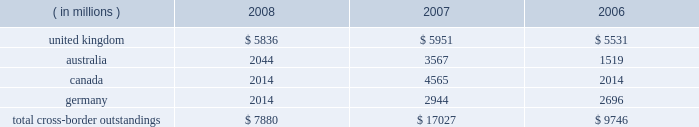Cross-border outstandings cross-border outstandings , as defined by bank regulatory rules , are amounts payable to state street by residents of foreign countries , regardless of the currency in which the claim is denominated , and local country claims in excess of local country obligations .
These cross-border outstandings consist primarily of deposits with banks , loan and lease financing and investment securities .
In addition to credit risk , cross-border outstandings have the risk that , as a result of political or economic conditions in a country , borrowers may be unable to meet their contractual repayment obligations of principal and/or interest when due because of the unavailability of , or restrictions on , foreign exchange needed by borrowers to repay their obligations .
Cross-border outstandings to countries in which we do business which amounted to at least 1% ( 1 % ) of our consolidated total assets were as follows as of december 31: .
The total cross-border outstandings presented in the table represented 5% ( 5 % ) , 12% ( 12 % ) and 9% ( 9 % ) of our consolidated total assets as of december 31 , 2008 , 2007 and 2006 , respectively .
Aggregate cross-border outstandings to countries which totaled between .75% ( .75 % ) and 1% ( 1 % ) of our consolidated total assets at december 31 , 2008 amounted to $ 3.45 billion ( canada and germany ) .
There were no cross-border outstandings to countries which totaled between .75% ( .75 % ) and 1% ( 1 % ) of our consolidated total assets as of december 31 , 2007 .
Aggregate cross-border outstandings to countries which totaled between .75% ( .75 % ) and 1% ( 1 % ) of our consolidated total assets at december 31 , 2006 amounted to $ 1.05 billion ( canada ) .
Capital regulatory and economic capital management both use key metrics evaluated by management to assess whether our actual level of capital is commensurate with our risk profile , is in compliance with all regulatory requirements , and is sufficient to provide us with the financial flexibility to undertake future strategic business initiatives .
Regulatory capital our objective with respect to regulatory capital management is to maintain a strong capital base in order to provide financial flexibility for our business needs , including funding corporate growth and supporting customers 2019 cash management needs , and to provide protection against loss to depositors and creditors .
We strive to maintain an optimal level of capital , commensurate with our risk profile , on which an attractive return to shareholders will be realized over both the short and long term , while protecting our obligations to depositors and creditors and satisfying regulatory requirements .
Our capital management process focuses on our risk exposures , our capital position relative to our peers , regulatory capital requirements and the evaluations of the major independent credit rating agencies that assign ratings to our public debt .
Our capital committee , working in conjunction with our asset and liability committee , referred to as alco , oversees the management of regulatory capital , and is responsible for ensuring capital adequacy with respect to regulatory requirements , internal targets and the expectations of the major independent credit rating agencies .
The primary regulator of both state street and state street bank for regulatory capital purposes is the federal reserve .
Both state street and state street bank are subject to the minimum capital requirements established by the federal reserve and defined in the federal deposit insurance corporation improvement act .
What are the consolidated total assets as of december 31 , 2007? 
Computations: (17027 / 12%)
Answer: 141891.66667. 